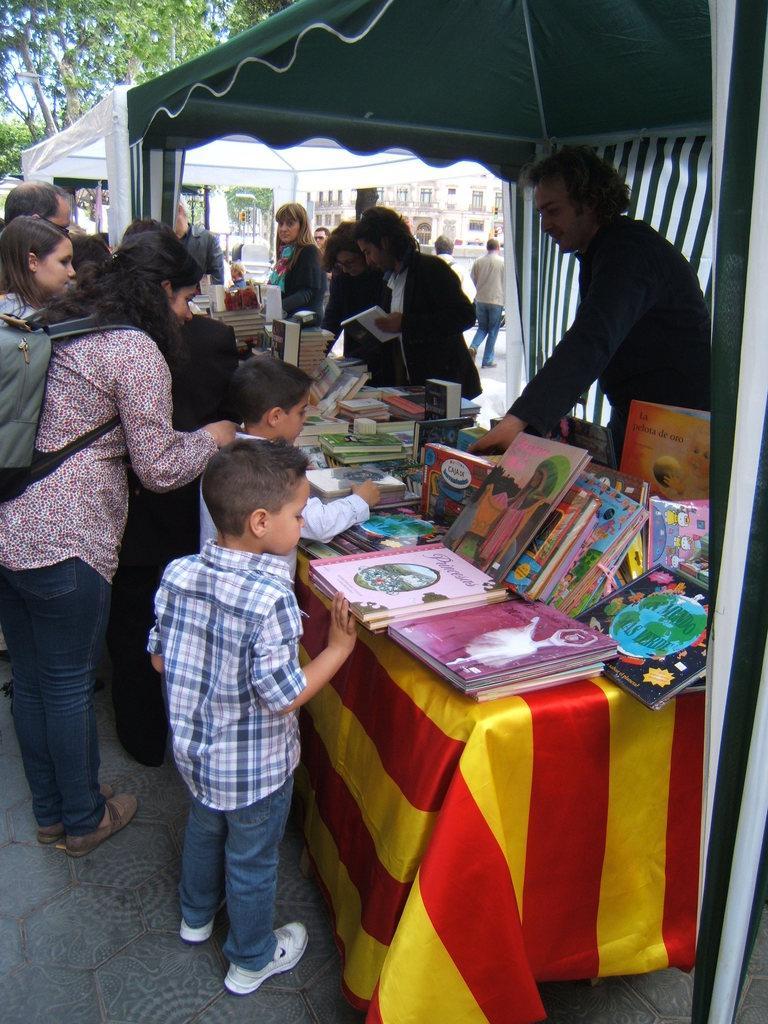Describe this image in one or two sentences. In this picture we can see some persons standing on the floor. This is table. On the table there are some books. On the background we can see a building. And this is the tree. 